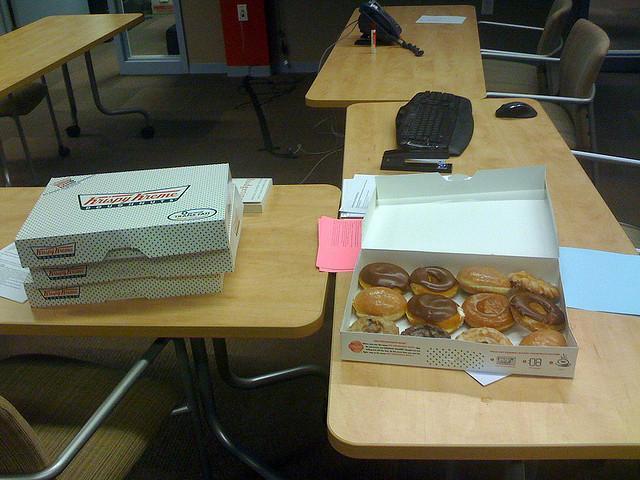How many donuts are in the open box?
Give a very brief answer. 12. How many boxes of donuts are there?
Give a very brief answer. 4. How many dining tables are in the picture?
Give a very brief answer. 3. How many chairs can you see?
Give a very brief answer. 2. 